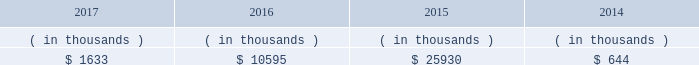Entergy mississippi may refinance , redeem , or otherwise retire debt and preferred stock prior to maturity , to the extent market conditions and interest and dividend rates are favorable .
All debt and common and preferred stock issuances by entergy mississippi require prior regulatory approval . a0 a0preferred stock and debt issuances are also subject to issuance tests set forth in its corporate charter , bond indenture , and other agreements . a0 a0entergy mississippi has sufficient capacity under these tests to meet its foreseeable capital needs .
Entergy mississippi 2019s receivables from the money pool were as follows as of december 31 for each of the following years. .
See note 4 to the financial statements for a description of the money pool .
Entergy mississippi has four separate credit facilities in the aggregate amount of $ 102.5 million scheduled to expire may 2018 .
No borrowings were outstanding under the credit facilities as of december a031 , 2017 . a0 a0in addition , entergy mississippi is a party to an uncommitted letter of credit facility as a means to post collateral to support its obligations to miso .
As of december a031 , 2017 , a $ 15.3 million letter of credit was outstanding under entergy mississippi 2019s uncommitted letter of credit facility .
See note 4 to the financial statements for additional discussion of the credit facilities .
Entergy mississippi obtained authorizations from the ferc through october 2019 for short-term borrowings not to exceed an aggregate amount of $ 175 million at any time outstanding and long-term borrowings and security issuances .
See note 4 to the financial statements for further discussion of entergy mississippi 2019s short-term borrowing limits .
Entergy mississippi , inc .
Management 2019s financial discussion and analysis state and local rate regulation and fuel-cost recovery the rates that entergy mississippi charges for electricity significantly influence its financial position , results of operations , and liquidity .
Entergy mississippi is regulated and the rates charged to its customers are determined in regulatory proceedings .
A governmental agency , the mpsc , is primarily responsible for approval of the rates charged to customers .
Formula rate plan in march 2016 , entergy mississippi submitted its formula rate plan 2016 test year filing showing entergy mississippi 2019s projected earned return for the 2016 calendar year to be below the formula rate plan bandwidth .
The filing showed a $ 32.6 million rate increase was necessary to reset entergy mississippi 2019s earned return on common equity to the specified point of adjustment of 9.96% ( 9.96 % ) , within the formula rate plan bandwidth .
In june 2016 the mpsc approved entergy mississippi 2019s joint stipulation with the mississippi public utilities staff .
The joint stipulation provided for a total revenue increase of $ 23.7 million .
The revenue increase includes a $ 19.4 million increase through the formula rate plan , resulting in a return on common equity point of adjustment of 10.07% ( 10.07 % ) .
The revenue increase also includes $ 4.3 million in incremental ad valorem tax expenses to be collected through an updated ad valorem tax adjustment rider .
The revenue increase and ad valorem tax adjustment rider were effective with the july 2016 bills .
In march 2017 , entergy mississippi submitted its formula rate plan 2017 test year filing and 2016 look-back filing showing entergy mississippi 2019s earned return for the historical 2016 calendar year and projected earned return for the 2017 calendar year to be within the formula rate plan bandwidth , resulting in no change in rates .
In june 2017 , entergy mississippi and the mississippi public utilities staff entered into a stipulation that confirmed that entergy .
What was the sum of the entergy mississippi 2019s receivables from the money pool from 2014 to 2017? 
Computations: ((1633 + 10595) + 25930)
Answer: 38158.0. 